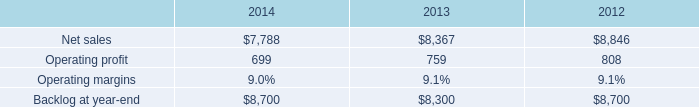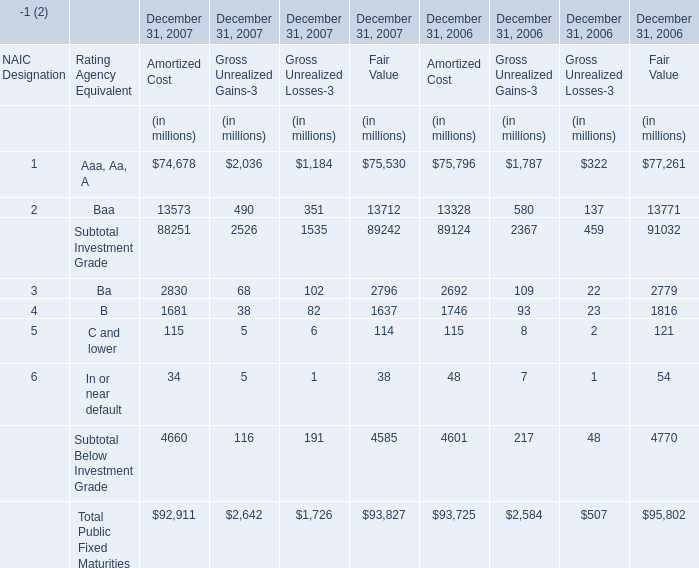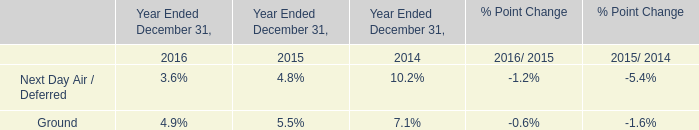what is the growth rate in operating profit from 2012 to 2013 for is&gs? 
Computations: ((759 - 808) / 808)
Answer: -0.06064. 